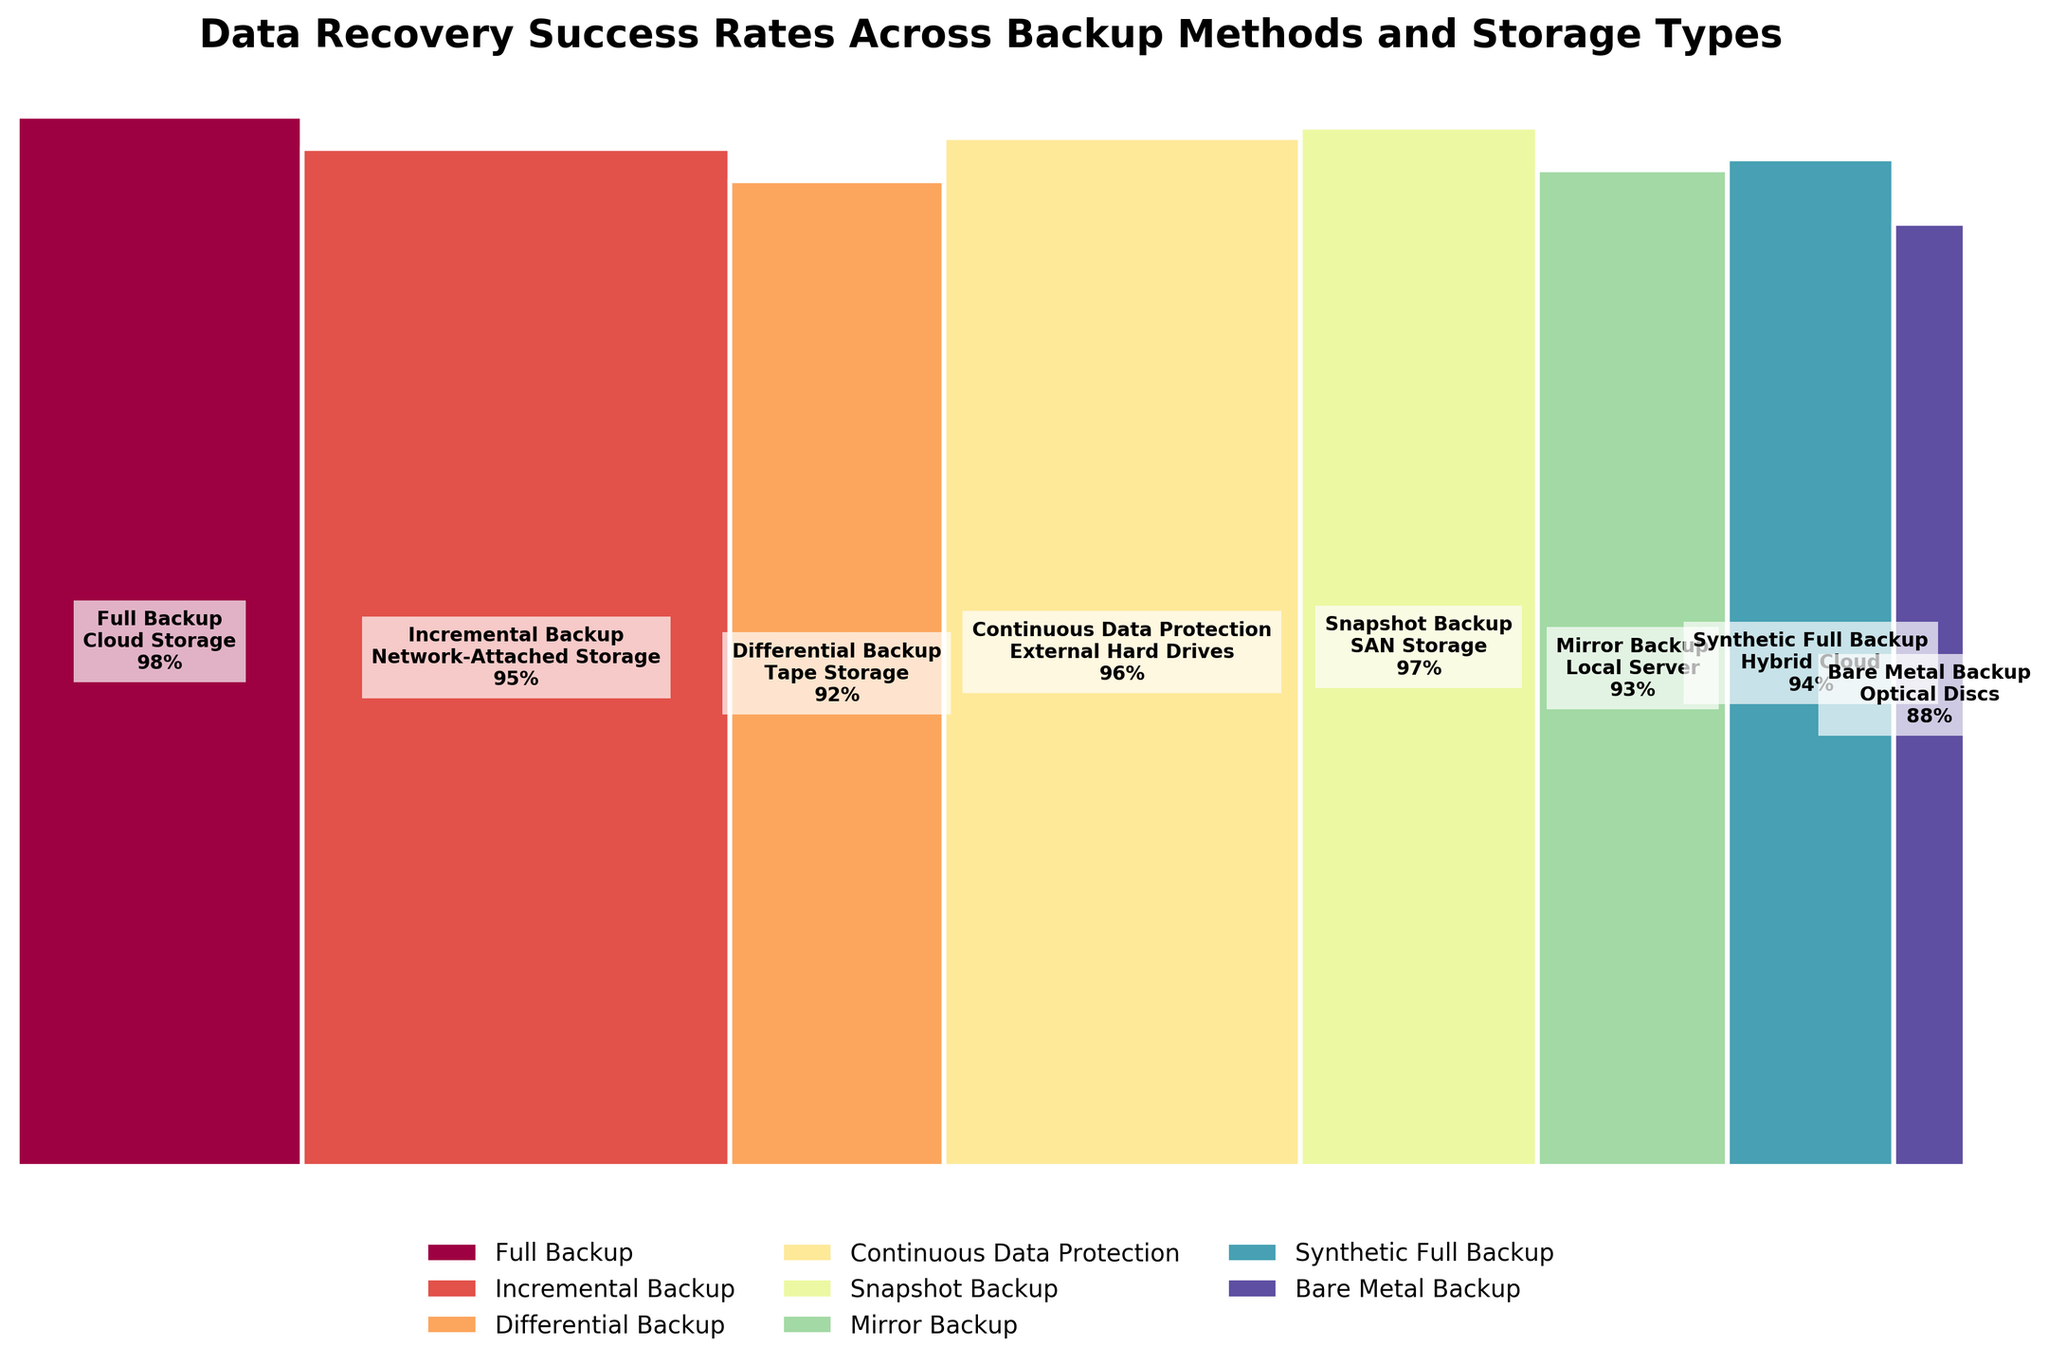Which backup method has the highest success rate? By observing the heights of the rectangles, the highest success rate corresponds to Full Backup, as indicated by the tallest rectangle, which shows 98%.
Answer: Full Backup What is the success rate for Differential Backup on Tape Storage? By locating the Differential Backup rectangle labeled with Tape Storage, the success rate mentioned is 92%.
Answer: 92% Which storage type corresponds to the highest data recovery frequency? By adding up the frequencies of all storage types and comparing them, Network-Attached Storage has the highest frequency of 180, linked to Incremental Backup.
Answer: Network-Attached Storage How does the recovery success rate of Full Backup on Cloud Storage compare to that of Mirror Backup on a Local Server? By comparing the heights of the rectangles labeled Full Backup and Mirror Backup, Full Backup has a higher success rate (98% vs 93%).
Answer: Full Backup (98%) > Mirror Backup (93%) What is the total frequency of backups with success rates above 95%? Summing the frequencies of methods with success rates above 95%, we get: Full Backup (120), Incremental Backup (180), Continuous Data Protection (150), and Snapshot Backup (100). Total: 120 + 180 + 150 + 100 = 550.
Answer: 550 Which backup method has the lowest success rate and what storage type does it use? By locating the shortest rectangle, Bare Metal Backup has the lowest success rate (88%), associated with Optical Discs.
Answer: Bare Metal Backup, Optical Discs What is the difference in success rates between Synthetic Full Backup on Hybrid Cloud and Differential Backup on Tape Storage? By locating the rectangles, Synthetic Full Backup has a 94% success rate, and Differential Backup has 92%. The difference is 94% - 92% = 2%.
Answer: 2% What is the width of the rectangle representing Incremental Backup on Network-Attached Storage compared to that of Bare Metal Backup on Optical Discs? Width is proportional to frequency. Incremental Backup has a frequency of 180, and Bare Metal Backup has 30. Incremental Backup’s rectangle is 180 / (120 + 180 + 90 + 150 + 100 + 80 + 70 + 30) = 0.3, and Bare Metal Backup’s rectangle is 30 / 820 ≈ 0.037. Incremental Backup is much wider.
Answer: Incremental Backup is much wider Which backup methods utilize more traditional storage media like Tape or Optical Discs? By identifying storage types, Differential Backup uses Tape Storage, and Bare Metal Backup uses Optical Discs.
Answer: Differential Backup, Bare Metal Backup What percentage of the total backup frequency is attributed to Continuous Data Protection on External Hard Drives? Dividing the frequency of Continuous Data Protection (150) by the total frequency (820) gives 150 / 820 ≈ 18.29%.
Answer: 18.29% 